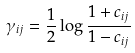<formula> <loc_0><loc_0><loc_500><loc_500>\gamma _ { i j } = \frac { 1 } { 2 } \log \frac { 1 + c _ { i j } } { 1 - c _ { i j } }</formula> 